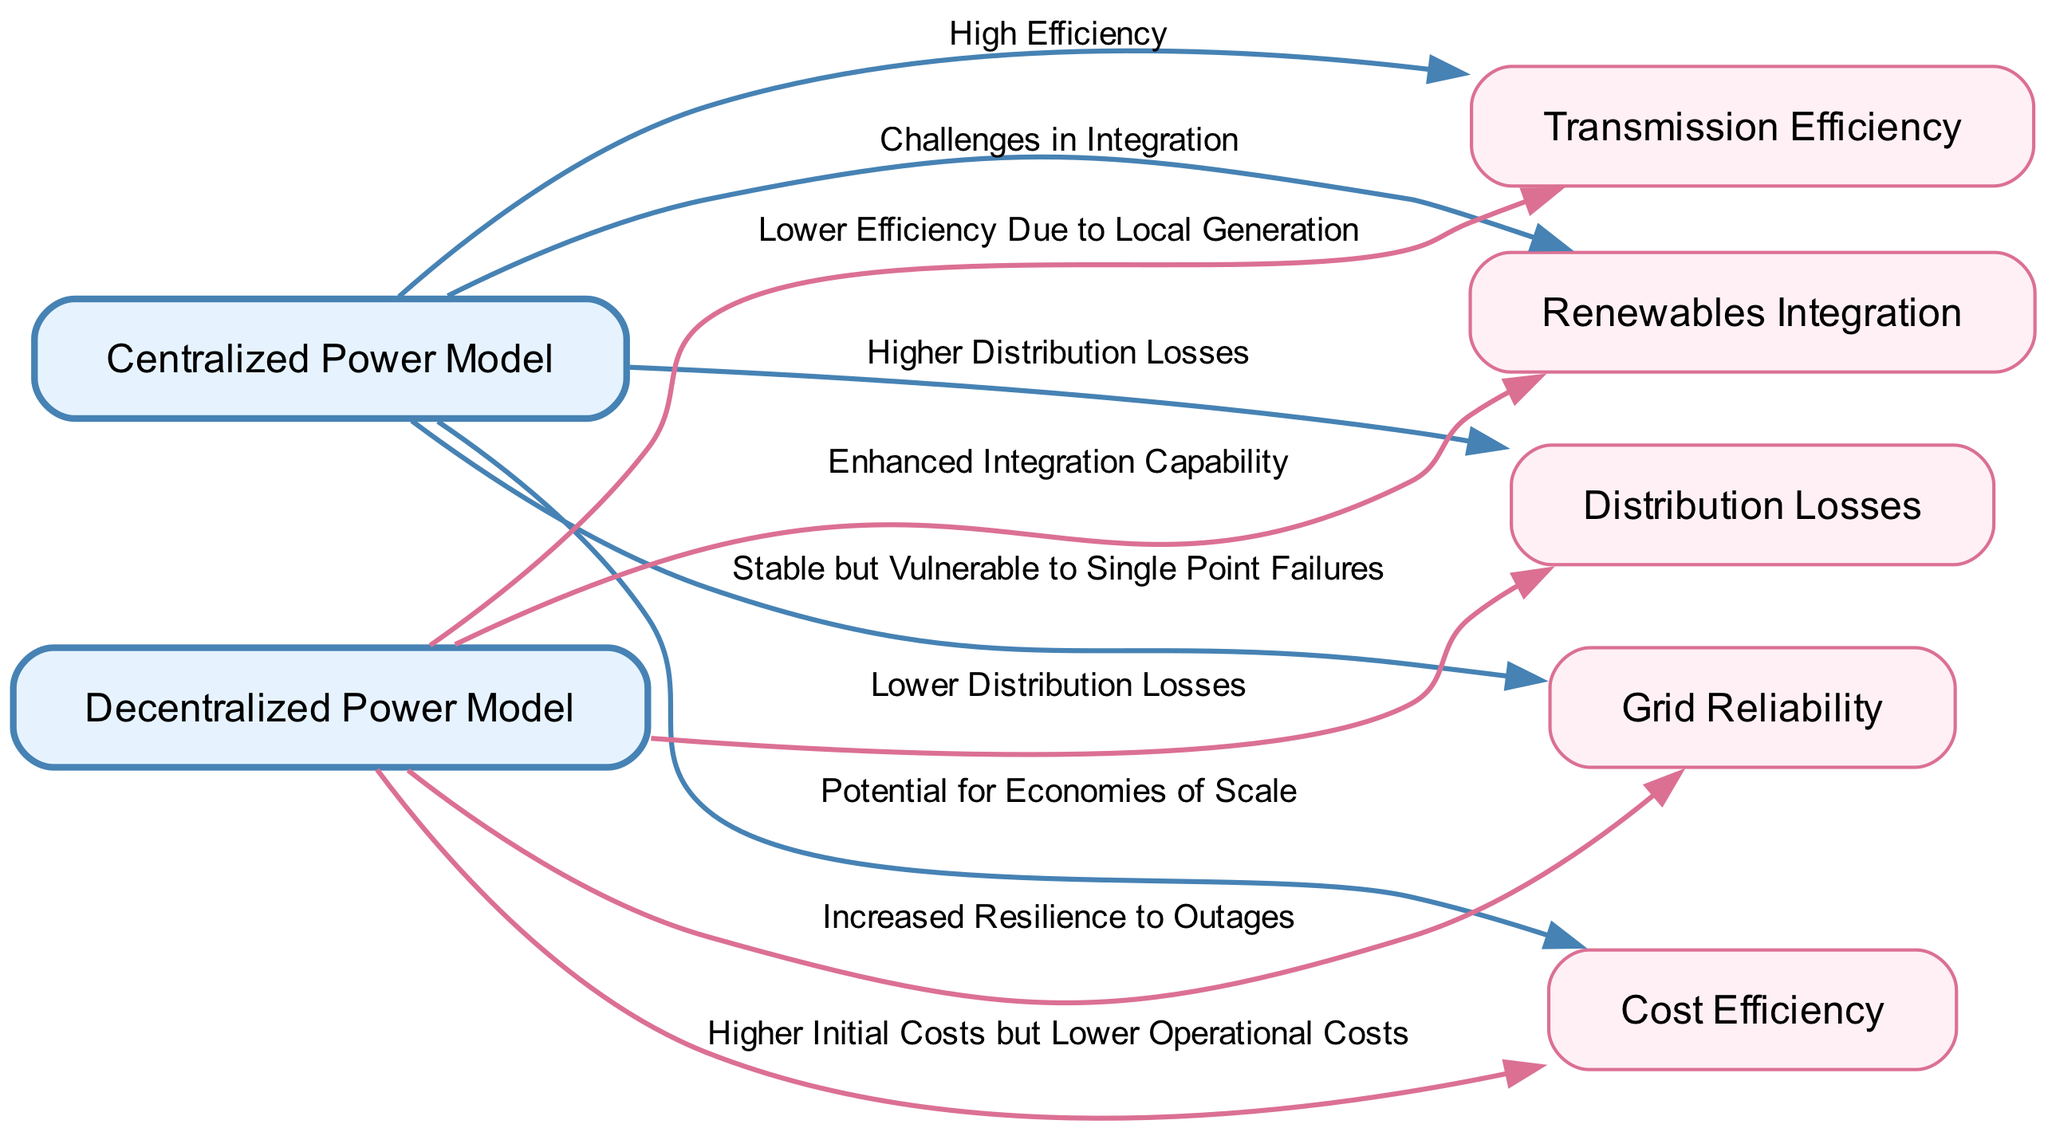What is the label of the node representing the model with higher transmission efficiency? The diagram shows that the node labeled "Centralized Power Model" connects to "Transmission Efficiency" with the label "High Efficiency." Hence, centralization leads to higher efficiency in transmission.
Answer: Centralized Power Model How many nodes are in the diagram? By counting the nodes listed in the provided data, there are a total of six nodes related to energy distribution efficiency.
Answer: 6 What relationship exists between Decentralized Power and Distribution Losses? The edge from the "Decentralized Power Model" to "Distribution Losses" is labeled "Lower Distribution Losses," indicating that decentralized systems have reduced energy losses during distribution compared to centralized systems.
Answer: Lower Distribution Losses What is the main advantage of decentralized power regarding renewables integration? According to the diagram, the edge from "Decentralized Power Model" to "Renewables Integration" indicates "Enhanced Integration Capability," suggesting that decentralized models facilitate better incorporation of renewable resources into the energy grid.
Answer: Enhanced Integration Capability Which model is noted for potential economies of scale in cost efficiency? The diagram connects the "Centralized Power Model" to "Cost Efficiency" with the label "Potential for Economies of Scale," which emphasizes that centralized models can leverage size for cost reductions.
Answer: Centralized Power Model What does the diagram suggest about grid reliability in a decentralized power model? The relationship from "Decentralized Power" to "Grid Reliability" notes "Increased Resilience to Outages," meaning the decentralized model provides improved reliability compared to a centralized approach.
Answer: Increased Resilience to Outages What does the edge indicate about transmission efficiency levels in decentralized power models? In the diagram, the connection from "Decentralized Power" to "Transmission Efficiency" is labeled "Lower Efficiency Due to Local Generation," revealing that local generation methods in decentralized models lead to decreased efficiency.
Answer: Lower Efficiency Due to Local Generation What type of power model faces challenges in integrating renewable sources? The diagram indicates that the "Centralized Power Model" is connected to "Renewables Integration" with the label "Challenges in Integration," which points to difficulties faced by centralized systems in adopting renewable energy.
Answer: Centralized Power Model Which model is associated with higher initial costs but potentially lower operational costs? From the diagram, the edge from "Decentralized Power Model" to "Cost Efficiency" specifies "Higher Initial Costs but Lower Operational Costs," reflecting the economic characteristics of decentralized systems.
Answer: Higher Initial Costs but Lower Operational Costs 